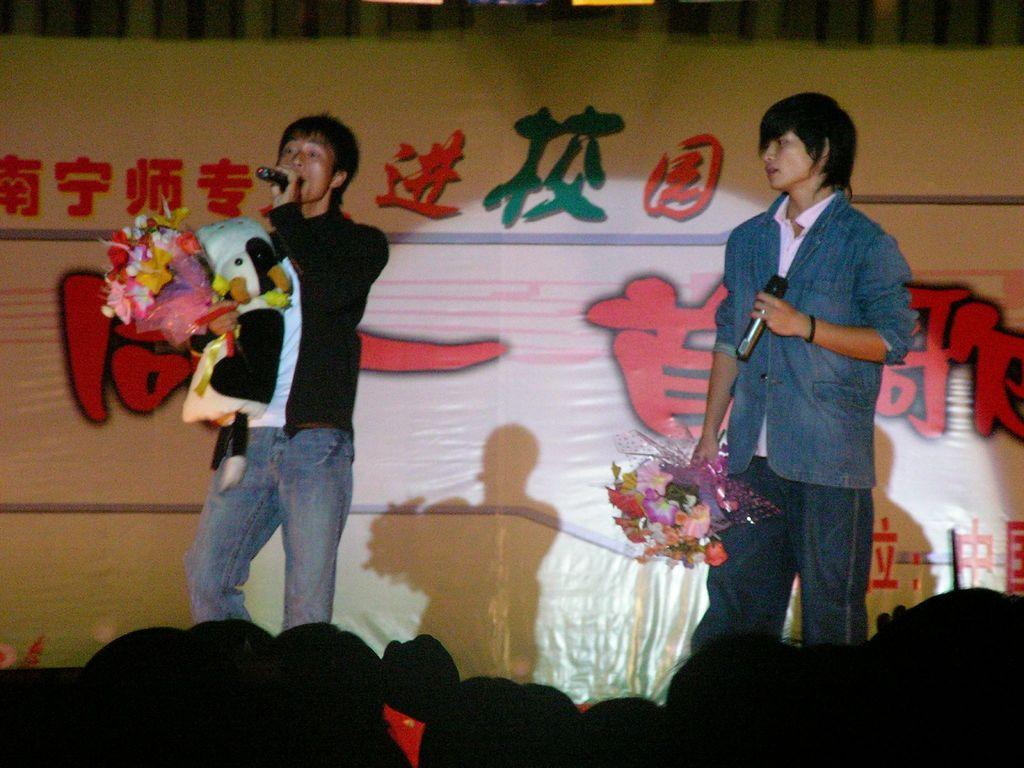Describe this image in one or two sentences. In this picture I can observe two men standing on the stage. Both of them are holding mics and bouquets in their hands. In front of them there are many people. In the background I can observe a flex. 